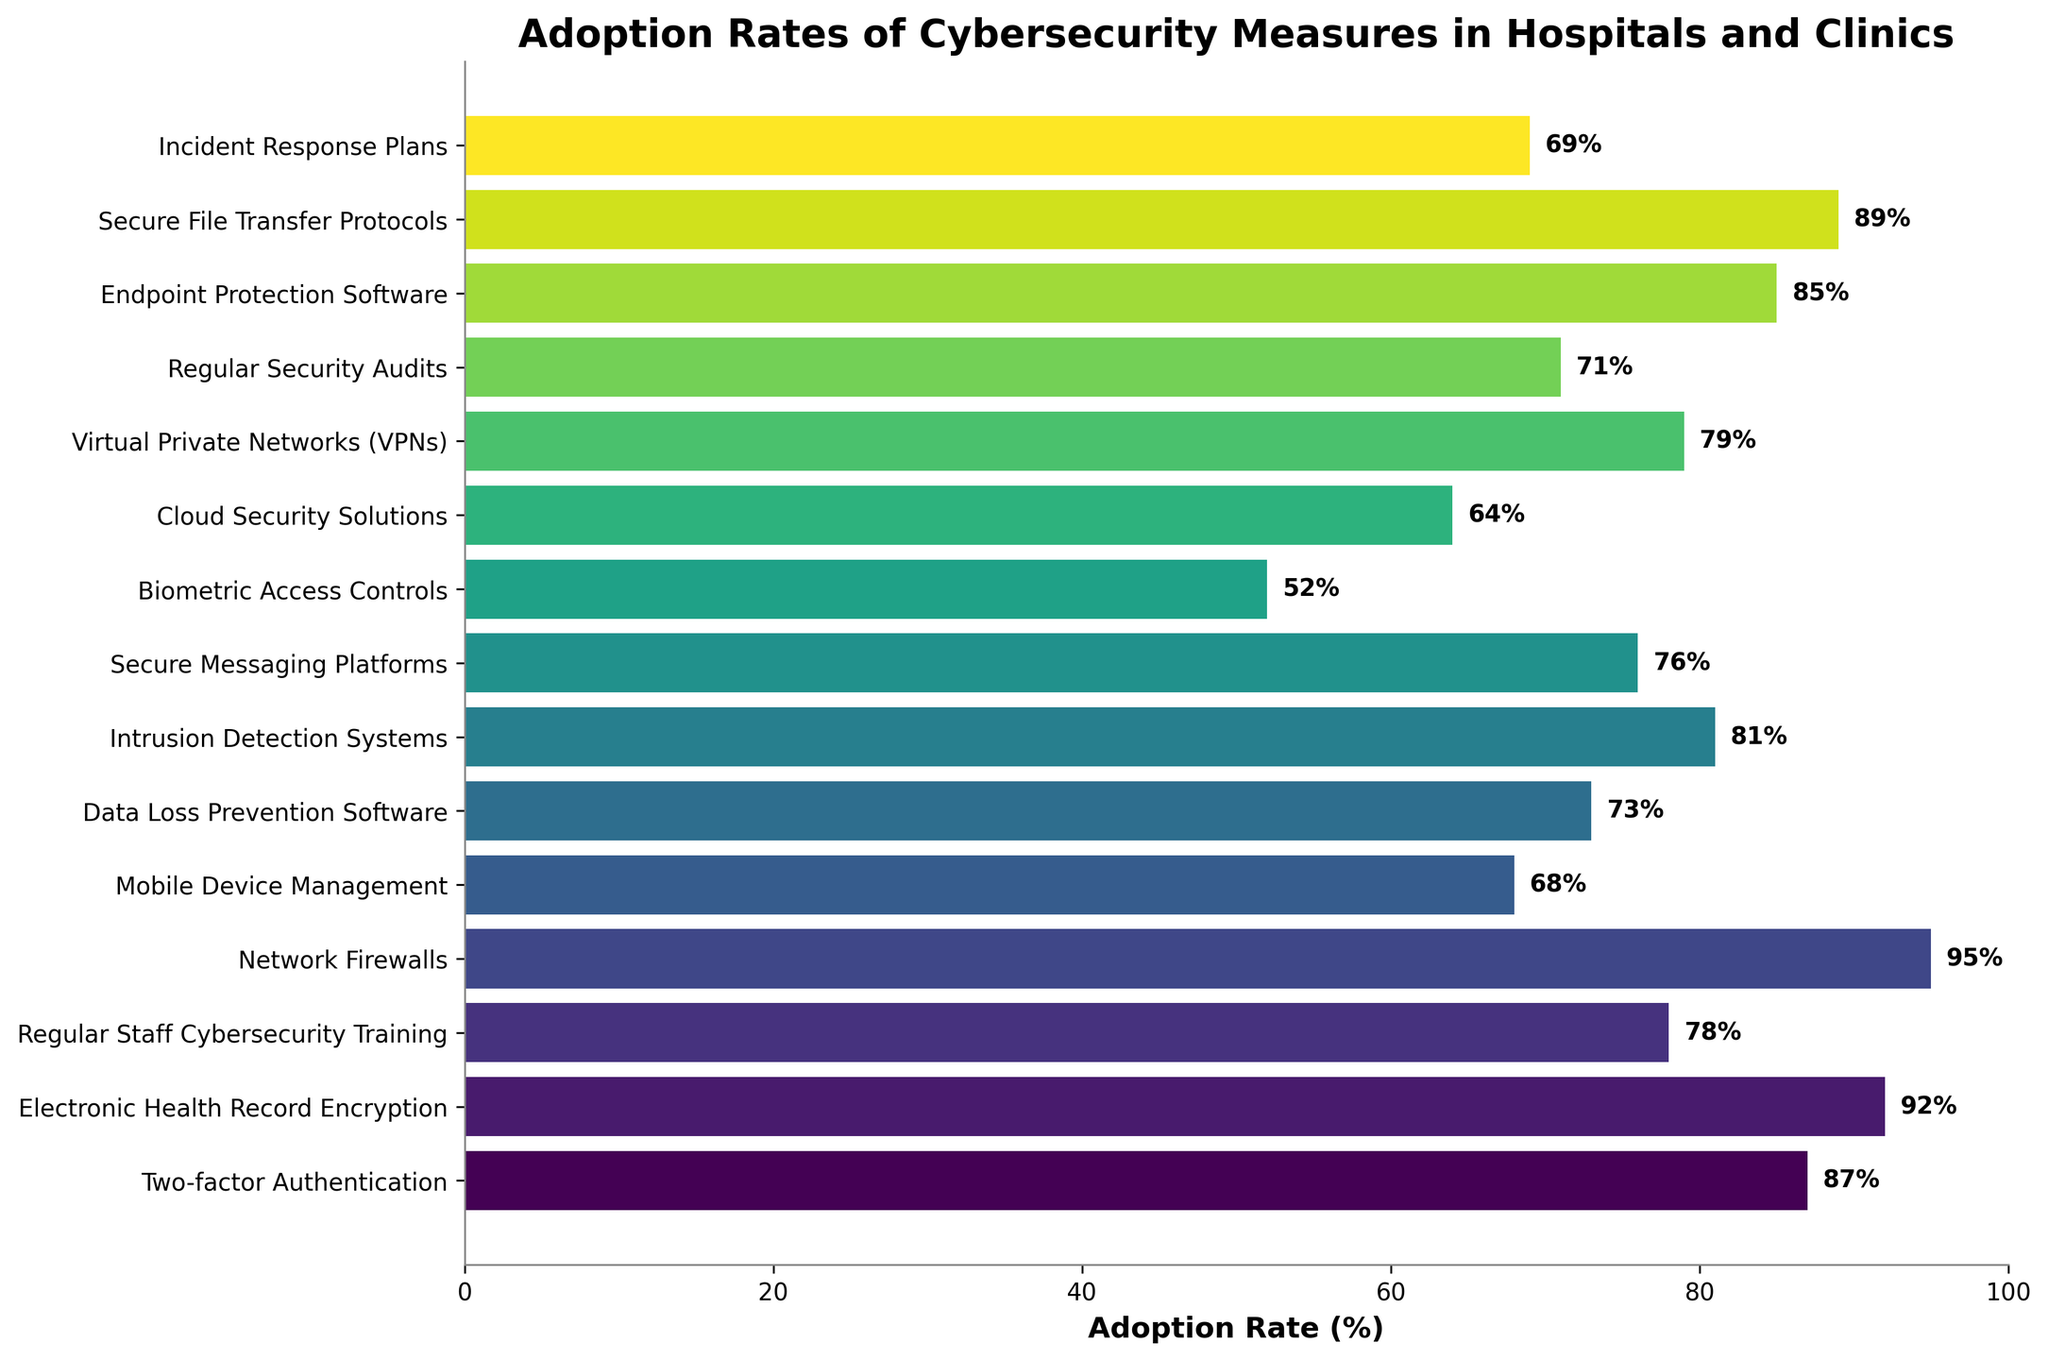What's the most widely adopted cybersecurity measure? By examining the bar chart, the bar representing "Network Firewalls" is the longest, indicating the highest adoption rate at 95%.
Answer: Network Firewalls What's the difference in adoption rates between the least and most adopted measures? Compare the lengths of the bars to identify the least adopted measure ("Biometric Access Controls" at 52%) and the most adopted measure ("Network Firewalls" at 95%). Subtract the smaller percentage from the larger one: 95% - 52% = 43%.
Answer: 43% Which cybersecurity measures have an adoption rate of 80% or higher? Identify bars with lengths extending to or beyond the 80% mark. They are "Two-factor Authentication" (87%), "Electronic Health Record Encryption" (92%), "Network Firewalls" (95%), "Intrusion Detection Systems" (81%), "Endpoint Protection Software" (85%), and "Secure File Transfer Protocols" (89%).
Answer: Two-factor Authentication, Electronic Health Record Encryption, Network Firewalls, Intrusion Detection Systems, Endpoint Protection Software, Secure File Transfer Protocols What's the average adoption rate of all the measures? Sum all the adoption rates and divide by the number of measures: (87 + 92 + 78 + 95 + 68 + 73 + 81 + 76 + 52 + 64 + 79 + 71 + 85 + 89 + 69) / 15 = 80%.
Answer: 80% Which measure has a higher adoption rate: "Data Loss Prevention Software" or "Regular Security Audits"? Compare the lengths of the bars for "Data Loss Prevention Software" (73%) and "Regular Security Audits" (71%). "Data Loss Prevention Software" has a higher rate.
Answer: Data Loss Prevention Software What's the combined adoption rate of "Two-factor Authentication" and "Incident Response Plans"? Add the adoption rates of the two measures: 87% + 69% = 156%.
Answer: 156% How many measures have an adoption rate below 70%? Identify bars shorter than the 70% mark: "Mobile Device Management" (68%), "Biometric Access Controls" (52%), "Cloud Security Solutions" (64%), and "Incident Response Plans" (69%). Four measures have rates below 70%.
Answer: 4 What's the median adoption rate of the measures? List the rates in ascending order: 52, 64, 68, 69, 71, 73, 76, 78, 79, 81, 85, 87, 89, 92, 95. The middle value in this ordered list is the eighth value (since there are 15 values), which is 78%.
Answer: 78% Which measure has a lower adoption rate: "Cloud Security Solutions" or "Virtual Private Networks (VPNs)"? Compare the lengths of the bars for "Cloud Security Solutions" (64%) and "Virtual Private Networks (VPNs)" (79%). "Cloud Security Solutions" has a lower rate.
Answer: Cloud Security Solutions What are the two measures with the closest adoption rates? Compare the differences in adoption rates between all adjacent bars' percentages. The closest rates are "Data Loss Prevention Software" (73%) and "Secure Messaging Platforms" (76%), with a difference of 3%.
Answer: Data Loss Prevention Software and Secure Messaging Platforms 